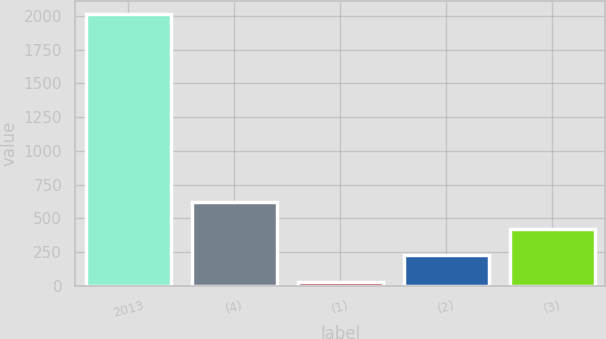Convert chart to OTSL. <chart><loc_0><loc_0><loc_500><loc_500><bar_chart><fcel>2013<fcel>(4)<fcel>(1)<fcel>(2)<fcel>(3)<nl><fcel>2011<fcel>621.5<fcel>26<fcel>224.5<fcel>423<nl></chart> 